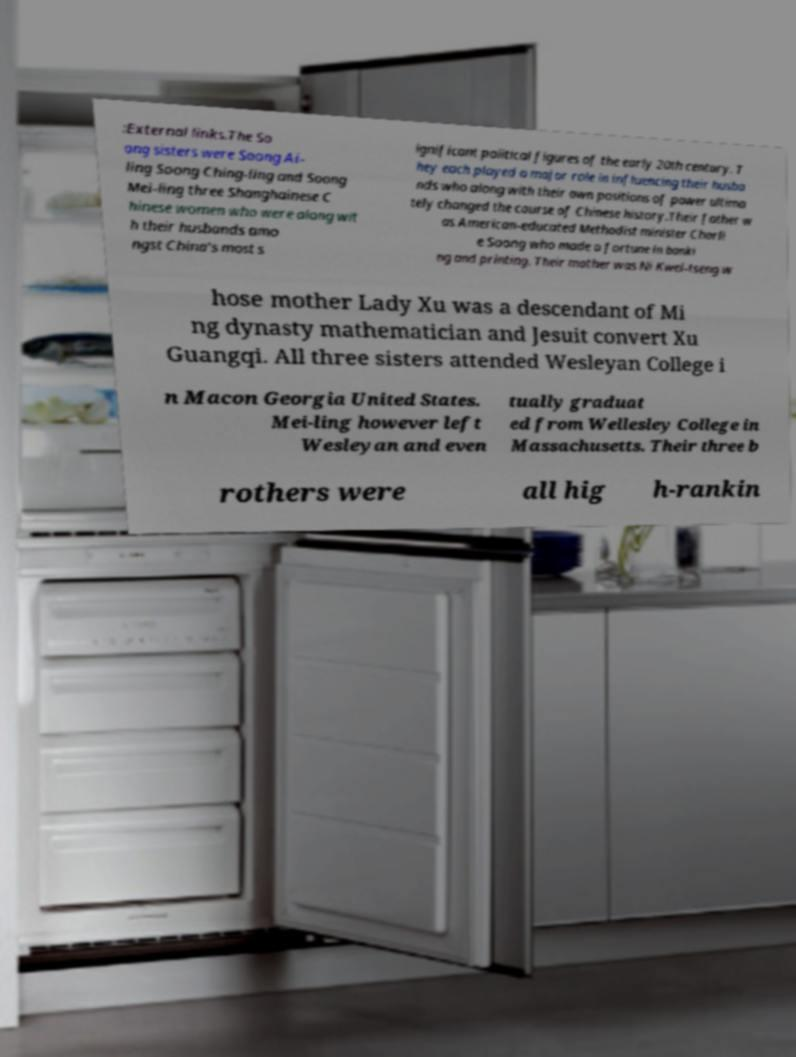What messages or text are displayed in this image? I need them in a readable, typed format. :External links.The So ong sisters were Soong Ai- ling Soong Ching-ling and Soong Mei-ling three Shanghainese C hinese women who were along wit h their husbands amo ngst China's most s ignificant political figures of the early 20th century. T hey each played a major role in influencing their husba nds who along with their own positions of power ultima tely changed the course of Chinese history.Their father w as American-educated Methodist minister Charli e Soong who made a fortune in banki ng and printing. Their mother was Ni Kwei-tseng w hose mother Lady Xu was a descendant of Mi ng dynasty mathematician and Jesuit convert Xu Guangqi. All three sisters attended Wesleyan College i n Macon Georgia United States. Mei-ling however left Wesleyan and even tually graduat ed from Wellesley College in Massachusetts. Their three b rothers were all hig h-rankin 